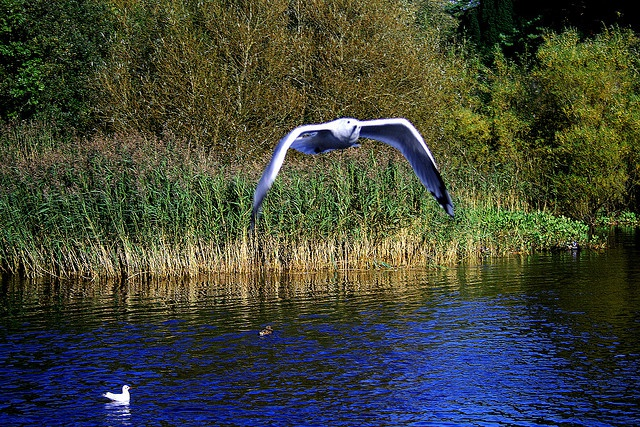Describe the objects in this image and their specific colors. I can see bird in darkgreen, navy, white, black, and blue tones, bird in darkgreen, white, black, violet, and navy tones, and bird in darkgreen, black, gray, olive, and maroon tones in this image. 